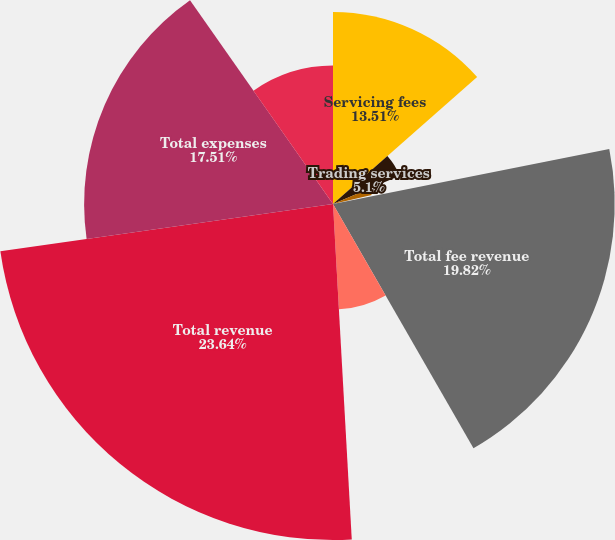<chart> <loc_0><loc_0><loc_500><loc_500><pie_chart><fcel>Servicing fees<fcel>Trading services<fcel>Securities finance<fcel>Processing fees and other<fcel>Total fee revenue<fcel>Net interest revenue<fcel>Total revenue<fcel>Total expenses<fcel>Income before income tax<nl><fcel>13.51%<fcel>5.1%<fcel>2.79%<fcel>0.47%<fcel>19.82%<fcel>7.42%<fcel>23.64%<fcel>17.51%<fcel>9.74%<nl></chart> 